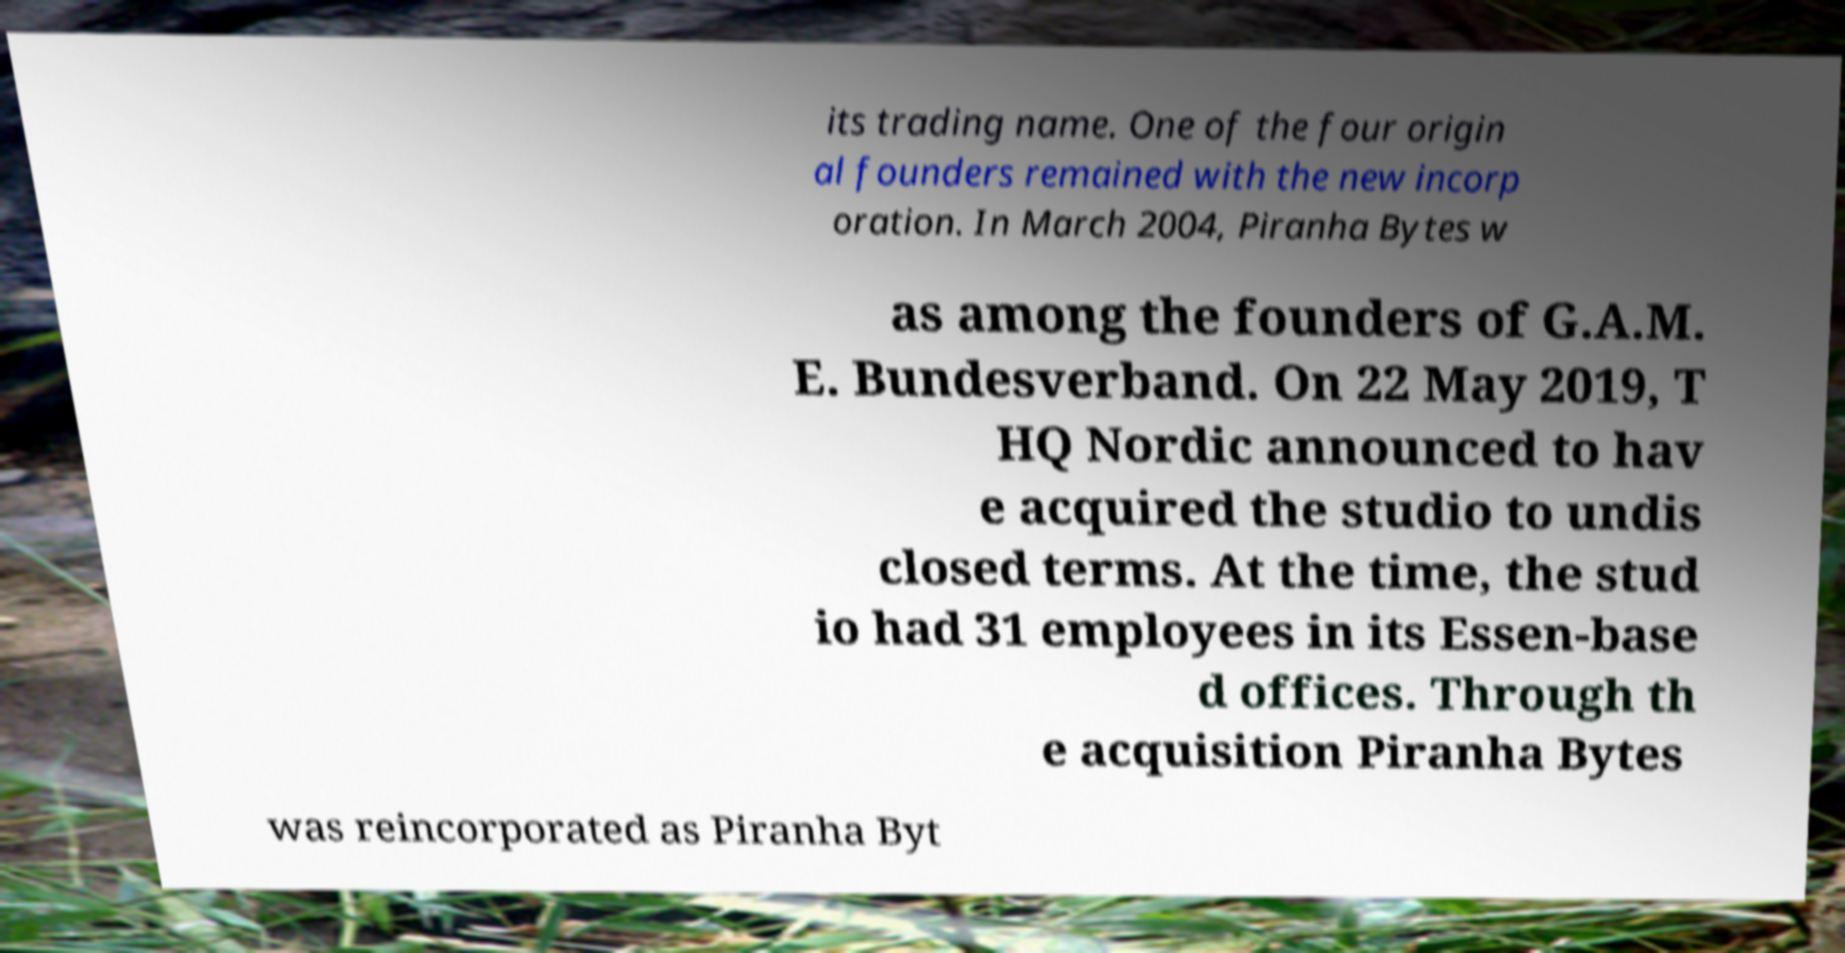Please identify and transcribe the text found in this image. its trading name. One of the four origin al founders remained with the new incorp oration. In March 2004, Piranha Bytes w as among the founders of G.A.M. E. Bundesverband. On 22 May 2019, T HQ Nordic announced to hav e acquired the studio to undis closed terms. At the time, the stud io had 31 employees in its Essen-base d offices. Through th e acquisition Piranha Bytes was reincorporated as Piranha Byt 